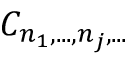<formula> <loc_0><loc_0><loc_500><loc_500>C _ { n _ { 1 } , \dots , n _ { j } , \dots }</formula> 